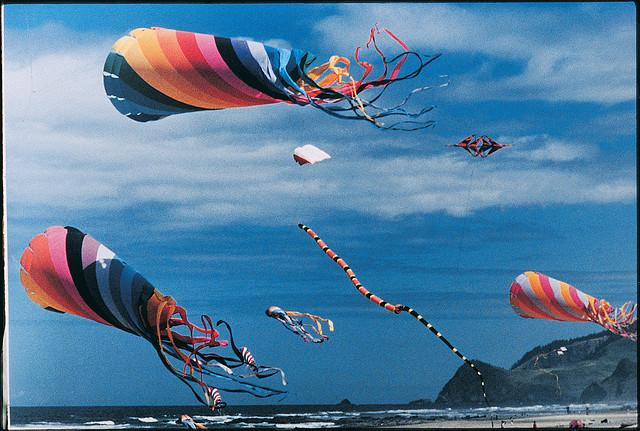What do the kites resemble? squid 